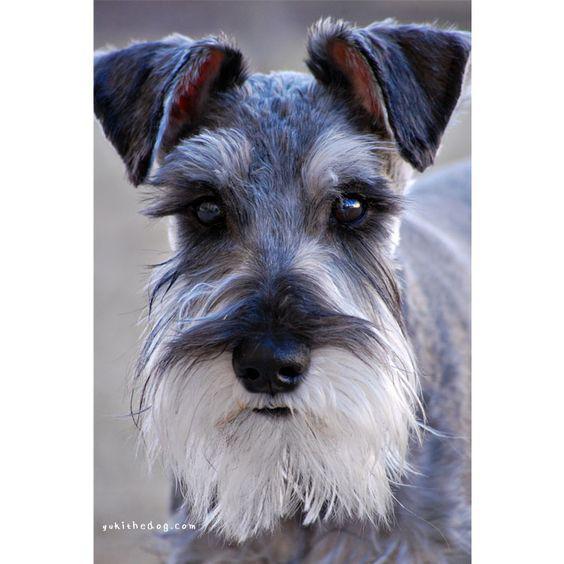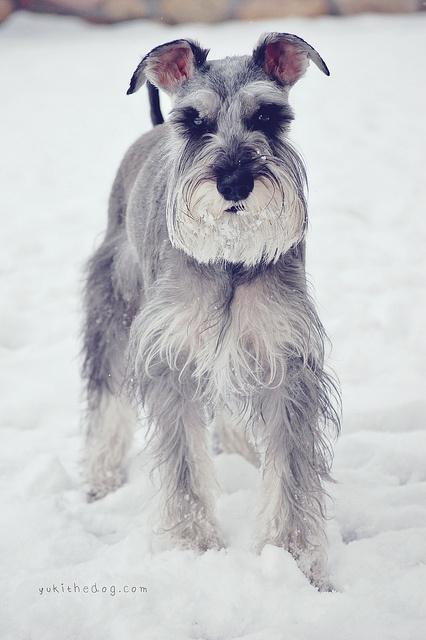The first image is the image on the left, the second image is the image on the right. For the images displayed, is the sentence "The right image shows a schnauzer standing in the snow." factually correct? Answer yes or no. Yes. 